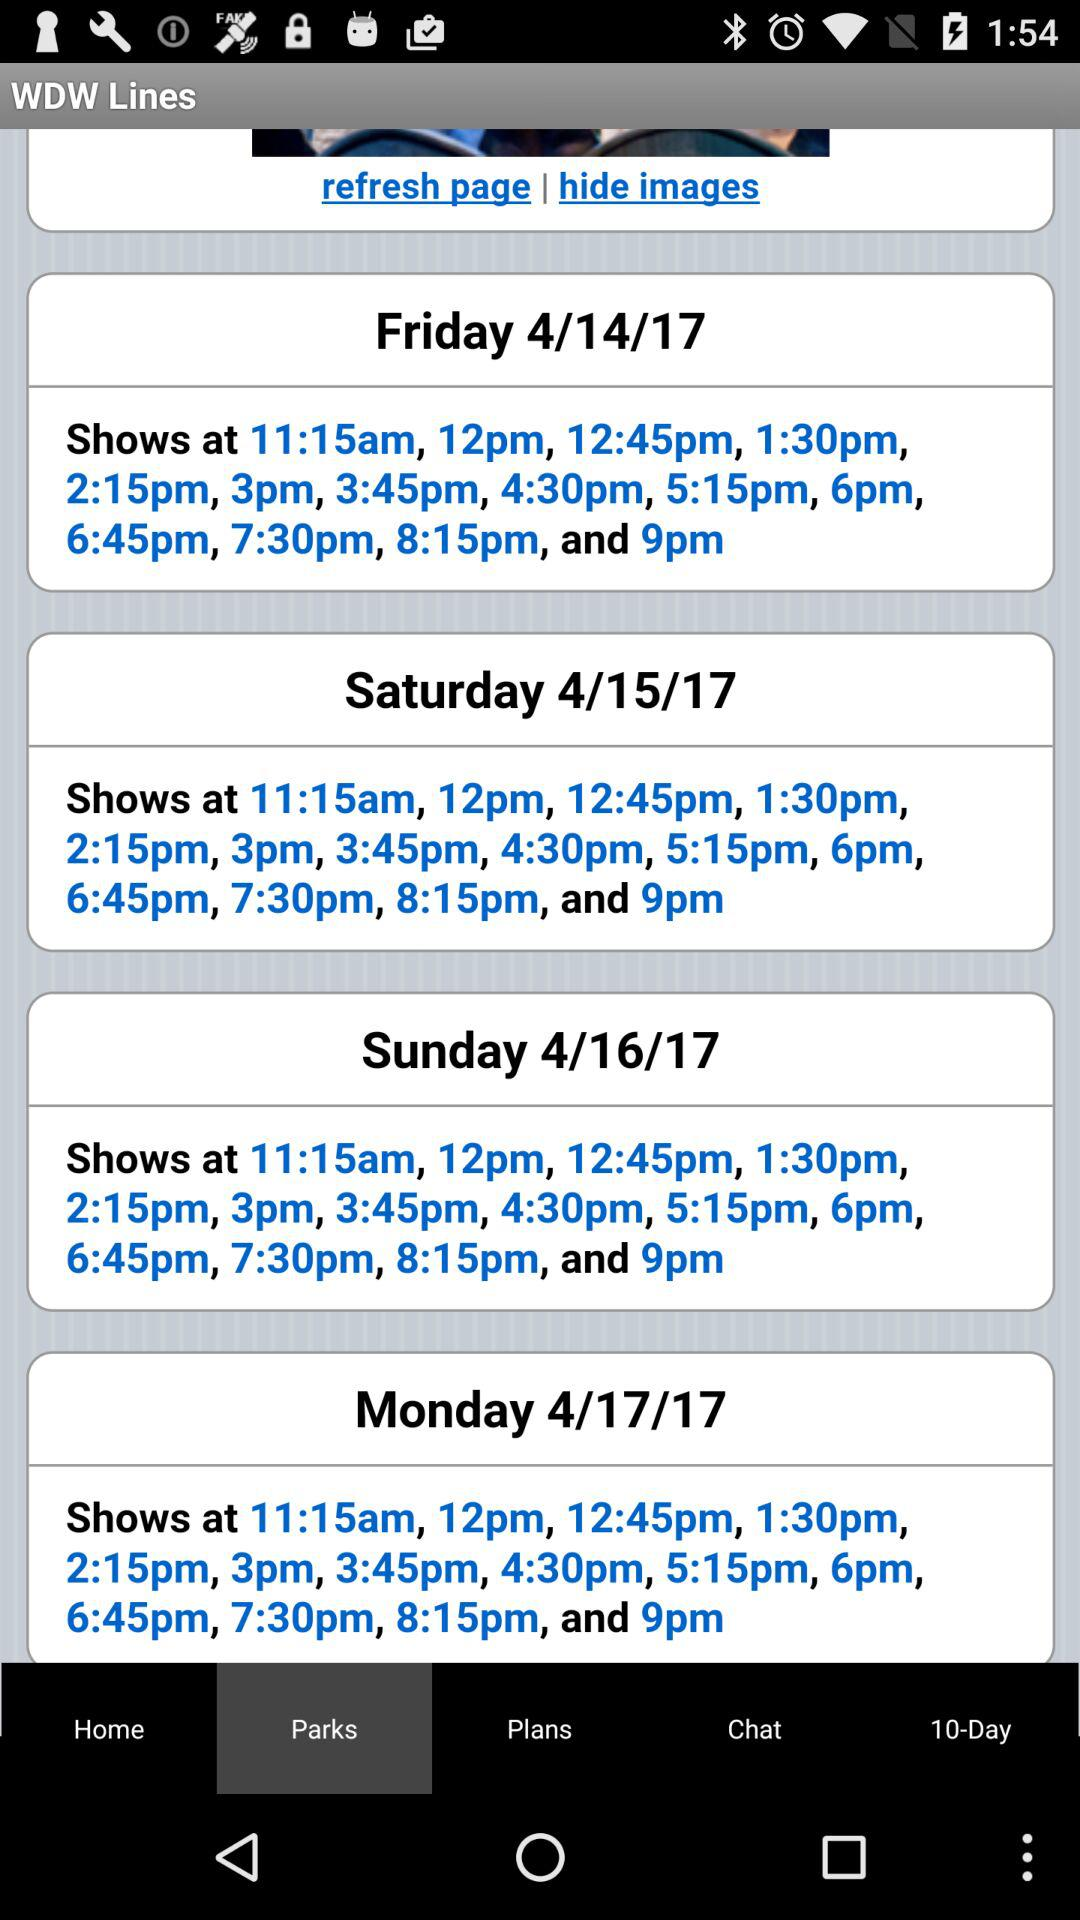Which tab am I now on? You are now on the "Parks" tab. 